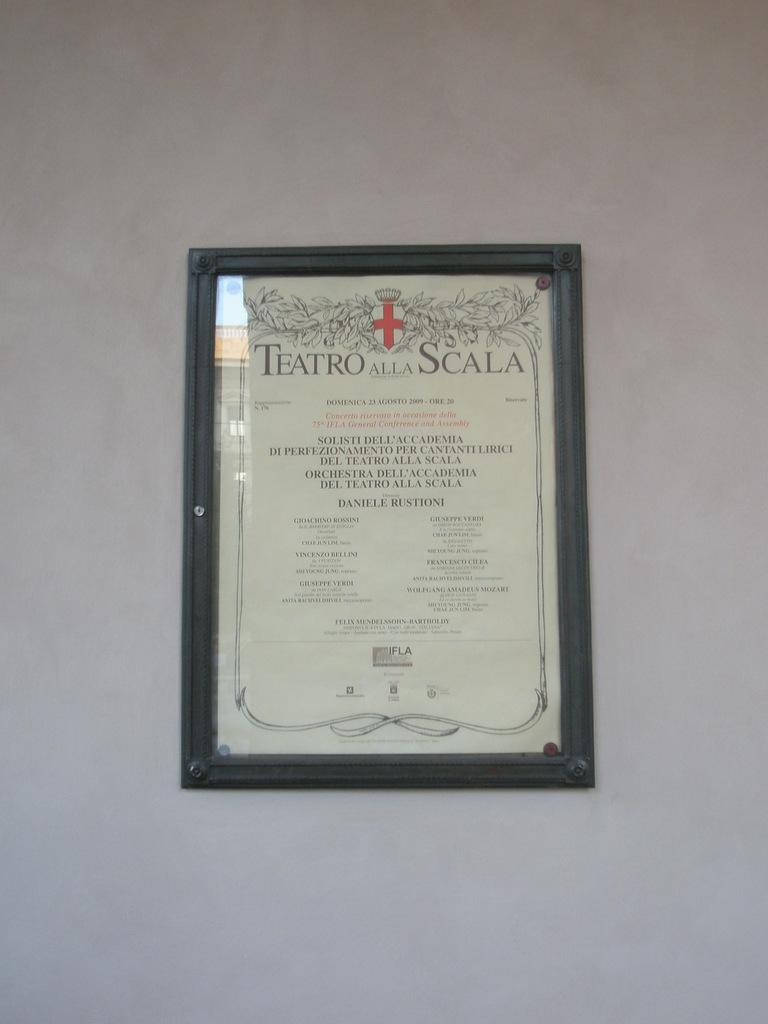<image>
Provide a brief description of the given image. The menu lists food items from Teatro Alla Scala. 